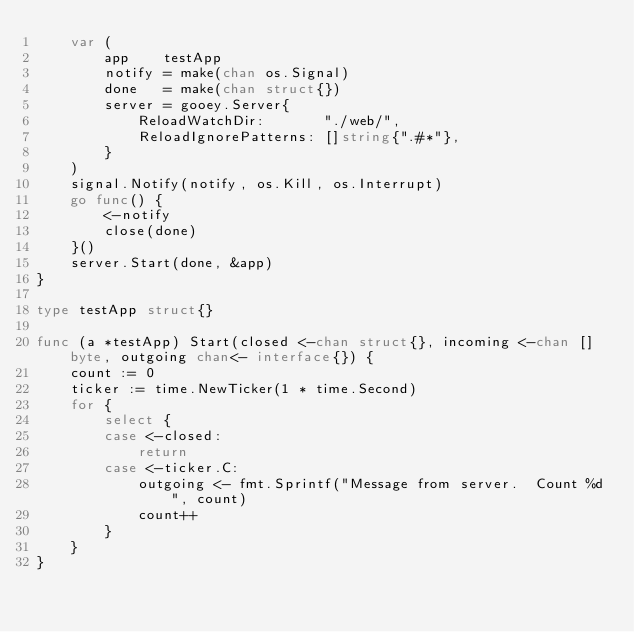Convert code to text. <code><loc_0><loc_0><loc_500><loc_500><_Go_>	var (
		app    testApp
		notify = make(chan os.Signal)
		done   = make(chan struct{})
		server = gooey.Server{
			ReloadWatchDir:       "./web/",
			ReloadIgnorePatterns: []string{".#*"},
		}
	)
	signal.Notify(notify, os.Kill, os.Interrupt)
	go func() {
		<-notify
		close(done)
	}()
	server.Start(done, &app)
}

type testApp struct{}

func (a *testApp) Start(closed <-chan struct{}, incoming <-chan []byte, outgoing chan<- interface{}) {
	count := 0
	ticker := time.NewTicker(1 * time.Second)
	for {
		select {
		case <-closed:
			return
		case <-ticker.C:
			outgoing <- fmt.Sprintf("Message from server.  Count %d", count)
			count++
		}
	}
}
</code> 